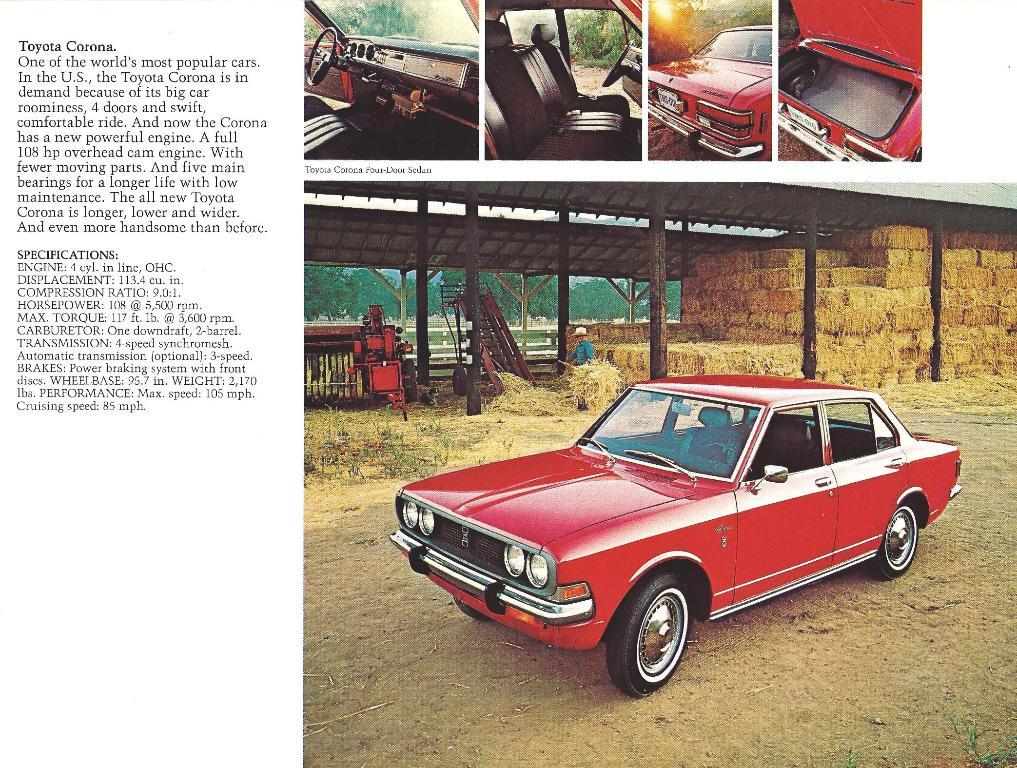What type of artwork is the image? The image is a collage. What mode of transportation can be seen in the image? There is a car in the image. Where is the car located in the image? The car is on the ground in the image. What is used to control the car's direction? There is a steering wheel in the image. What can be found inside the car? There are seats in the image. What type of natural scenery is present in the image? There are trees in the image. Who is present in the image? There is a person standing in the image. What is written or drawn on the left side of the image? There is text on the left side of the image. What type of bottle is being used to collect the sun's rays in the image? There is no bottle present in the image, nor is there any indication of collecting the sun's rays. 